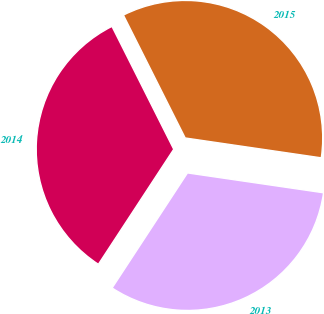Convert chart to OTSL. <chart><loc_0><loc_0><loc_500><loc_500><pie_chart><fcel>2015<fcel>2014<fcel>2013<nl><fcel>34.72%<fcel>33.35%<fcel>31.92%<nl></chart> 